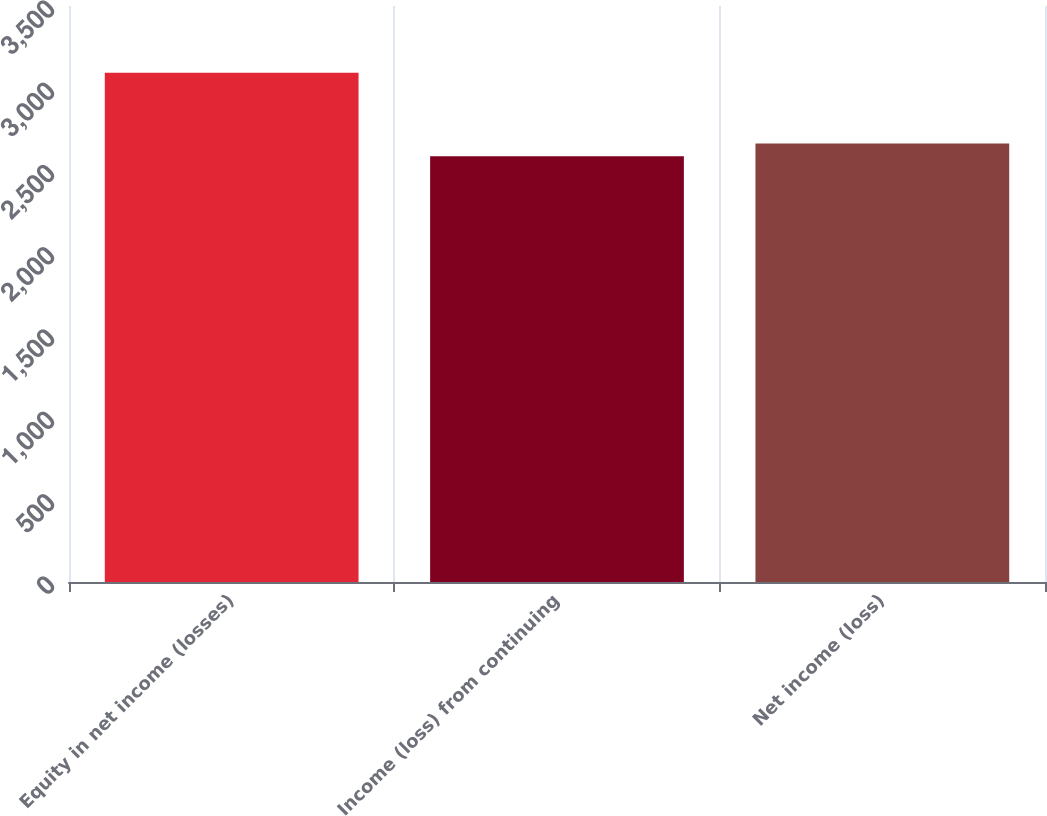Convert chart to OTSL. <chart><loc_0><loc_0><loc_500><loc_500><bar_chart><fcel>Equity in net income (losses)<fcel>Income (loss) from continuing<fcel>Net income (loss)<nl><fcel>3095<fcel>2587<fcel>2665.1<nl></chart> 